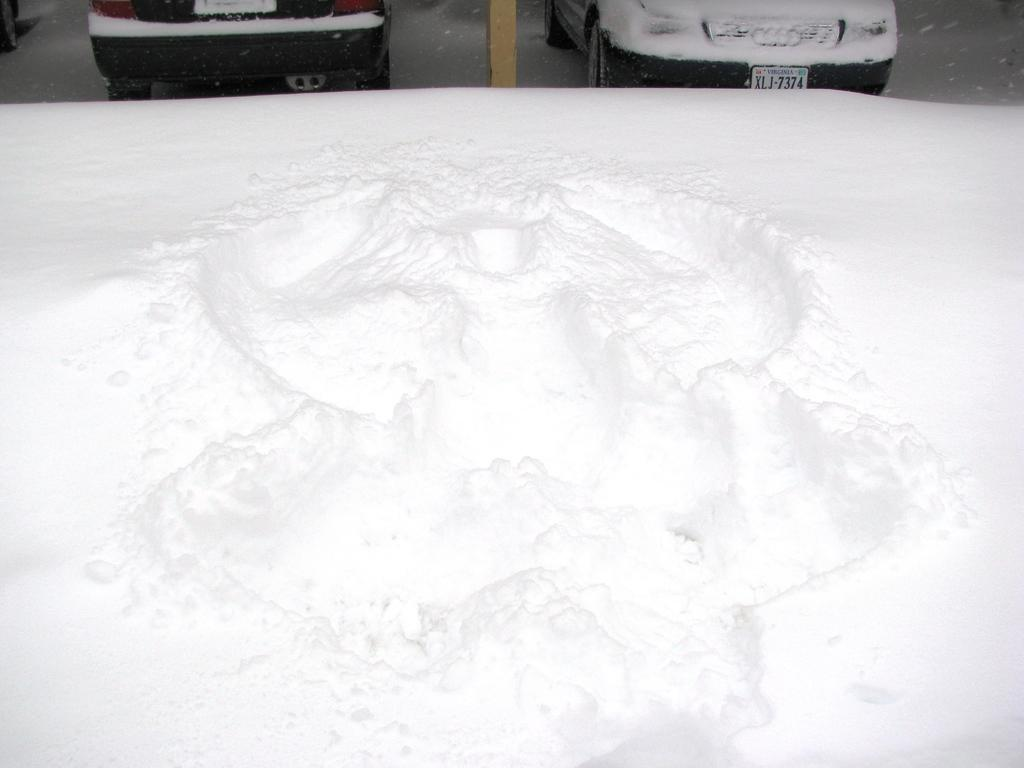What is the main feature in the center of the image? There is snow in the center of the image. What can be seen at the top side of the image? There are cars at the top side of the image. How many sisters are playing with the toy in the image? There is no toy or sisters present in the image. What is the slope of the hill in the image? There is no hill or slope present in the image; it only features snow and cars. 